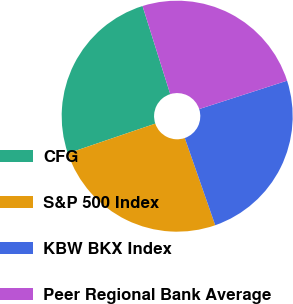<chart> <loc_0><loc_0><loc_500><loc_500><pie_chart><fcel>CFG<fcel>S&P 500 Index<fcel>KBW BKX Index<fcel>Peer Regional Bank Average<nl><fcel>25.37%<fcel>25.12%<fcel>24.63%<fcel>24.88%<nl></chart> 